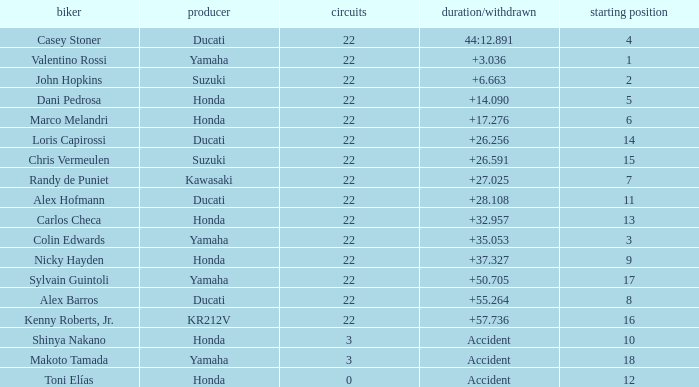Can you parse all the data within this table? {'header': ['biker', 'producer', 'circuits', 'duration/withdrawn', 'starting position'], 'rows': [['Casey Stoner', 'Ducati', '22', '44:12.891', '4'], ['Valentino Rossi', 'Yamaha', '22', '+3.036', '1'], ['John Hopkins', 'Suzuki', '22', '+6.663', '2'], ['Dani Pedrosa', 'Honda', '22', '+14.090', '5'], ['Marco Melandri', 'Honda', '22', '+17.276', '6'], ['Loris Capirossi', 'Ducati', '22', '+26.256', '14'], ['Chris Vermeulen', 'Suzuki', '22', '+26.591', '15'], ['Randy de Puniet', 'Kawasaki', '22', '+27.025', '7'], ['Alex Hofmann', 'Ducati', '22', '+28.108', '11'], ['Carlos Checa', 'Honda', '22', '+32.957', '13'], ['Colin Edwards', 'Yamaha', '22', '+35.053', '3'], ['Nicky Hayden', 'Honda', '22', '+37.327', '9'], ['Sylvain Guintoli', 'Yamaha', '22', '+50.705', '17'], ['Alex Barros', 'Ducati', '22', '+55.264', '8'], ['Kenny Roberts, Jr.', 'KR212V', '22', '+57.736', '16'], ['Shinya Nakano', 'Honda', '3', 'Accident', '10'], ['Makoto Tamada', 'Yamaha', '3', 'Accident', '18'], ['Toni Elías', 'Honda', '0', 'Accident', '12']]} What is the average grid for the competitiors who had laps smaller than 3? 12.0. 